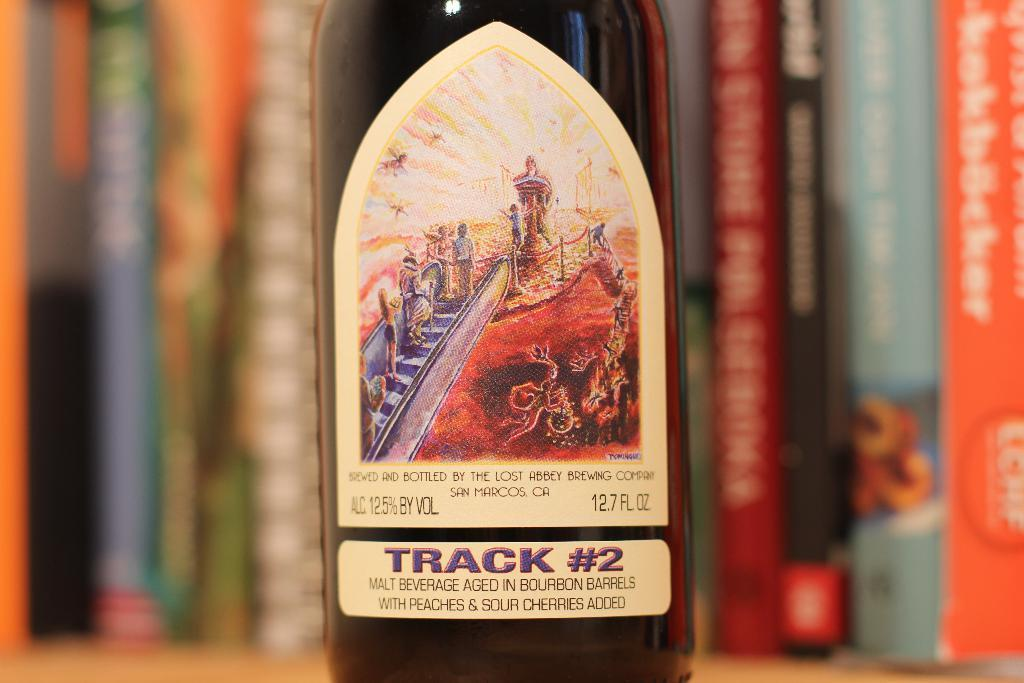Provide a one-sentence caption for the provided image. A closeup of a malt beverage bottle labeled track #2. 